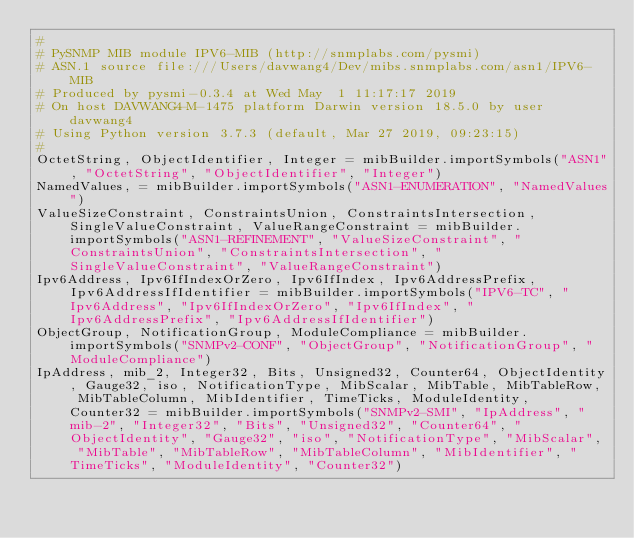Convert code to text. <code><loc_0><loc_0><loc_500><loc_500><_Python_>#
# PySNMP MIB module IPV6-MIB (http://snmplabs.com/pysmi)
# ASN.1 source file:///Users/davwang4/Dev/mibs.snmplabs.com/asn1/IPV6-MIB
# Produced by pysmi-0.3.4 at Wed May  1 11:17:17 2019
# On host DAVWANG4-M-1475 platform Darwin version 18.5.0 by user davwang4
# Using Python version 3.7.3 (default, Mar 27 2019, 09:23:15) 
#
OctetString, ObjectIdentifier, Integer = mibBuilder.importSymbols("ASN1", "OctetString", "ObjectIdentifier", "Integer")
NamedValues, = mibBuilder.importSymbols("ASN1-ENUMERATION", "NamedValues")
ValueSizeConstraint, ConstraintsUnion, ConstraintsIntersection, SingleValueConstraint, ValueRangeConstraint = mibBuilder.importSymbols("ASN1-REFINEMENT", "ValueSizeConstraint", "ConstraintsUnion", "ConstraintsIntersection", "SingleValueConstraint", "ValueRangeConstraint")
Ipv6Address, Ipv6IfIndexOrZero, Ipv6IfIndex, Ipv6AddressPrefix, Ipv6AddressIfIdentifier = mibBuilder.importSymbols("IPV6-TC", "Ipv6Address", "Ipv6IfIndexOrZero", "Ipv6IfIndex", "Ipv6AddressPrefix", "Ipv6AddressIfIdentifier")
ObjectGroup, NotificationGroup, ModuleCompliance = mibBuilder.importSymbols("SNMPv2-CONF", "ObjectGroup", "NotificationGroup", "ModuleCompliance")
IpAddress, mib_2, Integer32, Bits, Unsigned32, Counter64, ObjectIdentity, Gauge32, iso, NotificationType, MibScalar, MibTable, MibTableRow, MibTableColumn, MibIdentifier, TimeTicks, ModuleIdentity, Counter32 = mibBuilder.importSymbols("SNMPv2-SMI", "IpAddress", "mib-2", "Integer32", "Bits", "Unsigned32", "Counter64", "ObjectIdentity", "Gauge32", "iso", "NotificationType", "MibScalar", "MibTable", "MibTableRow", "MibTableColumn", "MibIdentifier", "TimeTicks", "ModuleIdentity", "Counter32")</code> 